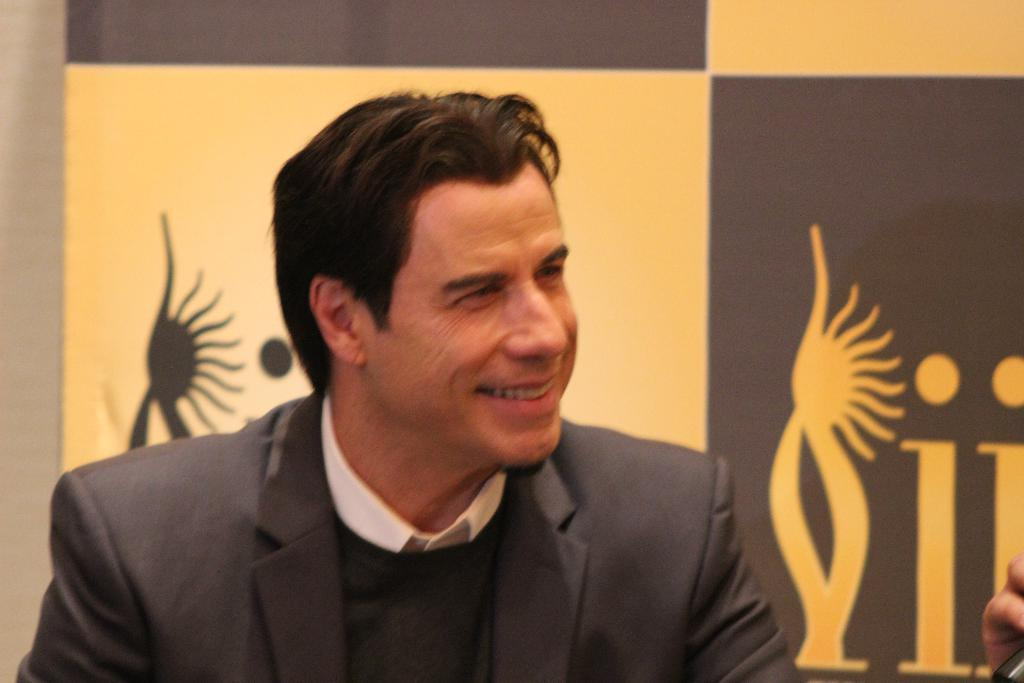Who is present in the image? There is a person in the image. What is the person doing in the image? The person is smiling. What is the person wearing in the image? The person is wearing a black and white color dress. What can be seen in the background of the image? There is a cream and brown color banner in the background of the image. Where is the field located in the image? There is no field present in the image. Can you see a swing in the image? There is no swing present in the image. 